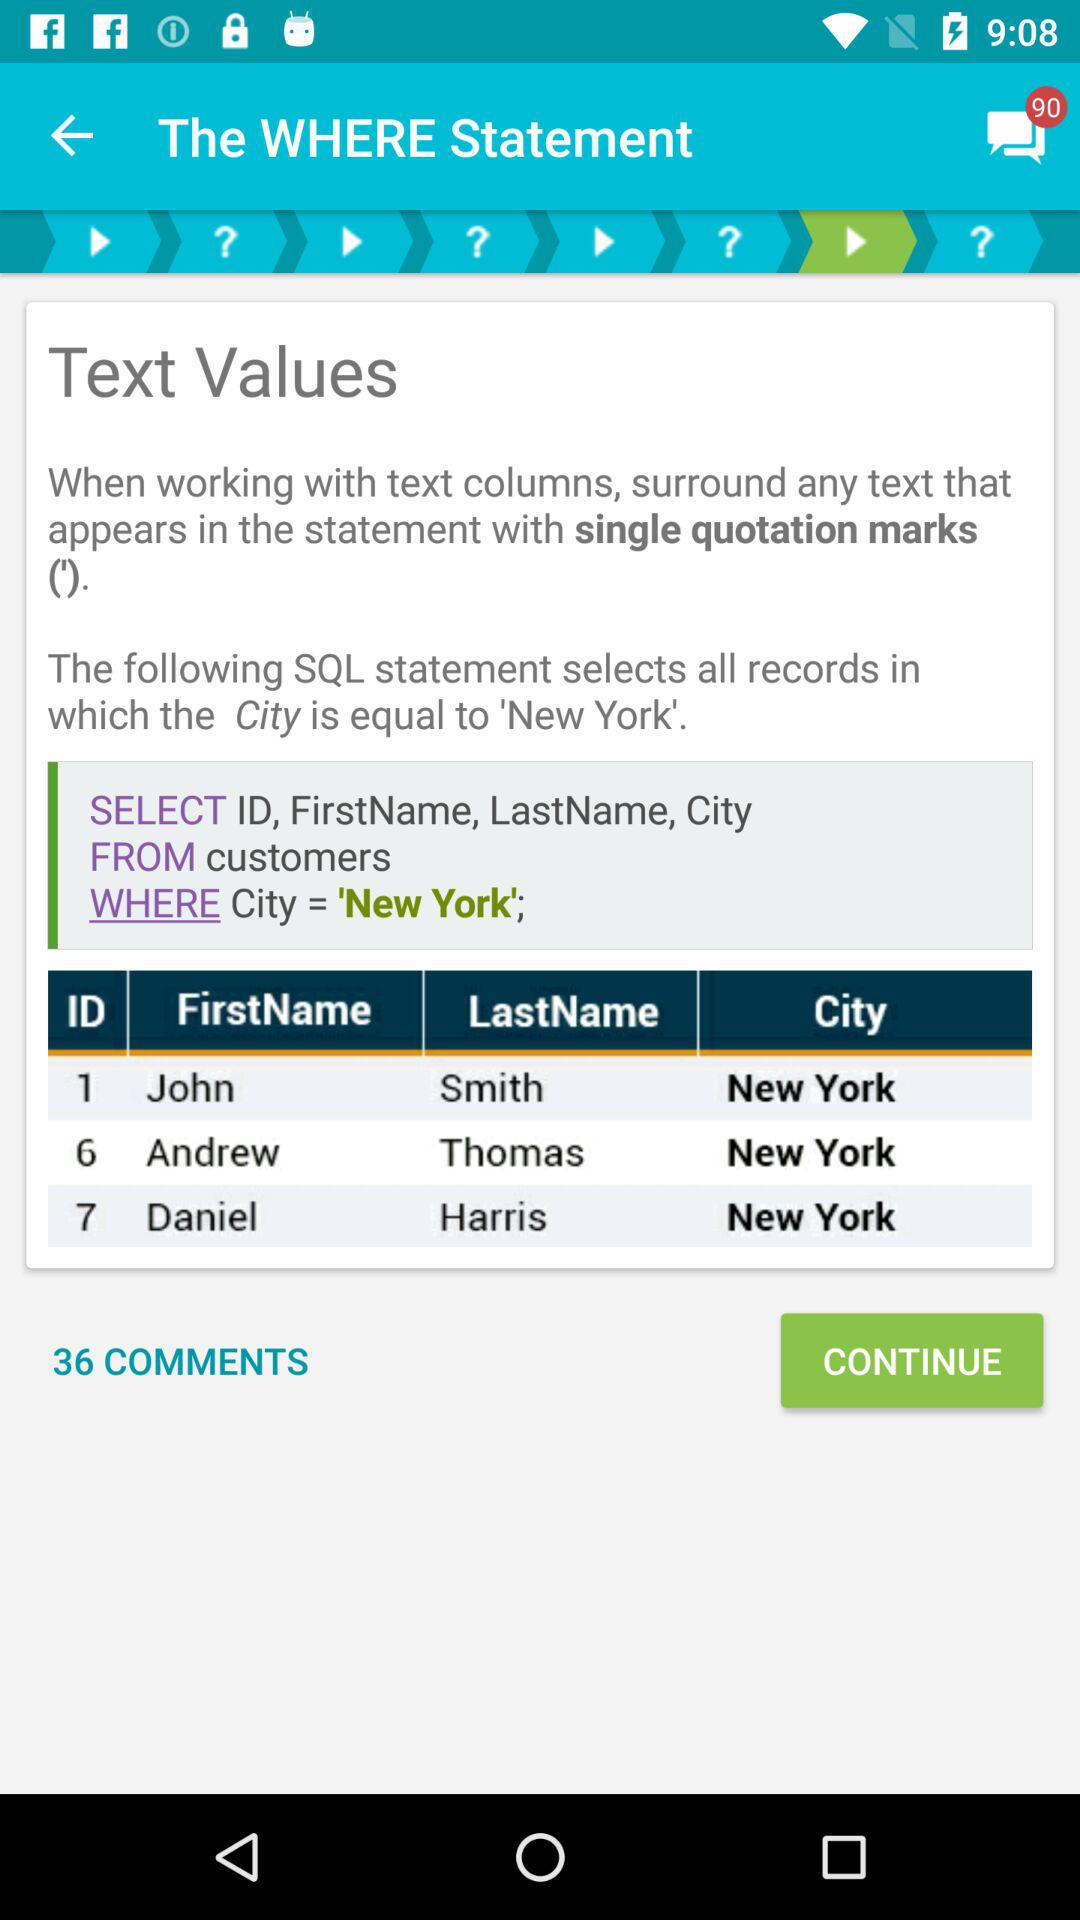How many text values are surrounded by single quotation marks in the SQL statement?
Answer the question using a single word or phrase. 1 